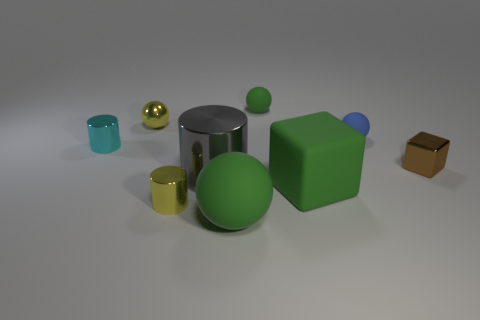What is the small brown cube made of?
Your answer should be very brief. Metal. What material is the green ball behind the sphere that is in front of the large green matte object that is behind the large ball?
Provide a succinct answer. Rubber. Does the cyan cylinder that is behind the big gray metal object have the same size as the green rubber object that is behind the cyan shiny cylinder?
Offer a terse response. Yes. What number of other objects are the same material as the brown thing?
Provide a short and direct response. 4. What number of metallic objects are either big green objects or large brown cylinders?
Your answer should be compact. 0. Is the number of tiny shiny spheres less than the number of green shiny cylinders?
Ensure brevity in your answer.  No. There is a cyan cylinder; is it the same size as the green matte sphere behind the tiny cyan thing?
Provide a short and direct response. Yes. Are there any other things that are the same shape as the cyan metal thing?
Keep it short and to the point. Yes. The cyan shiny cylinder has what size?
Give a very brief answer. Small. Are there fewer blue matte balls in front of the green matte cube than small yellow metallic cylinders?
Provide a short and direct response. Yes. 